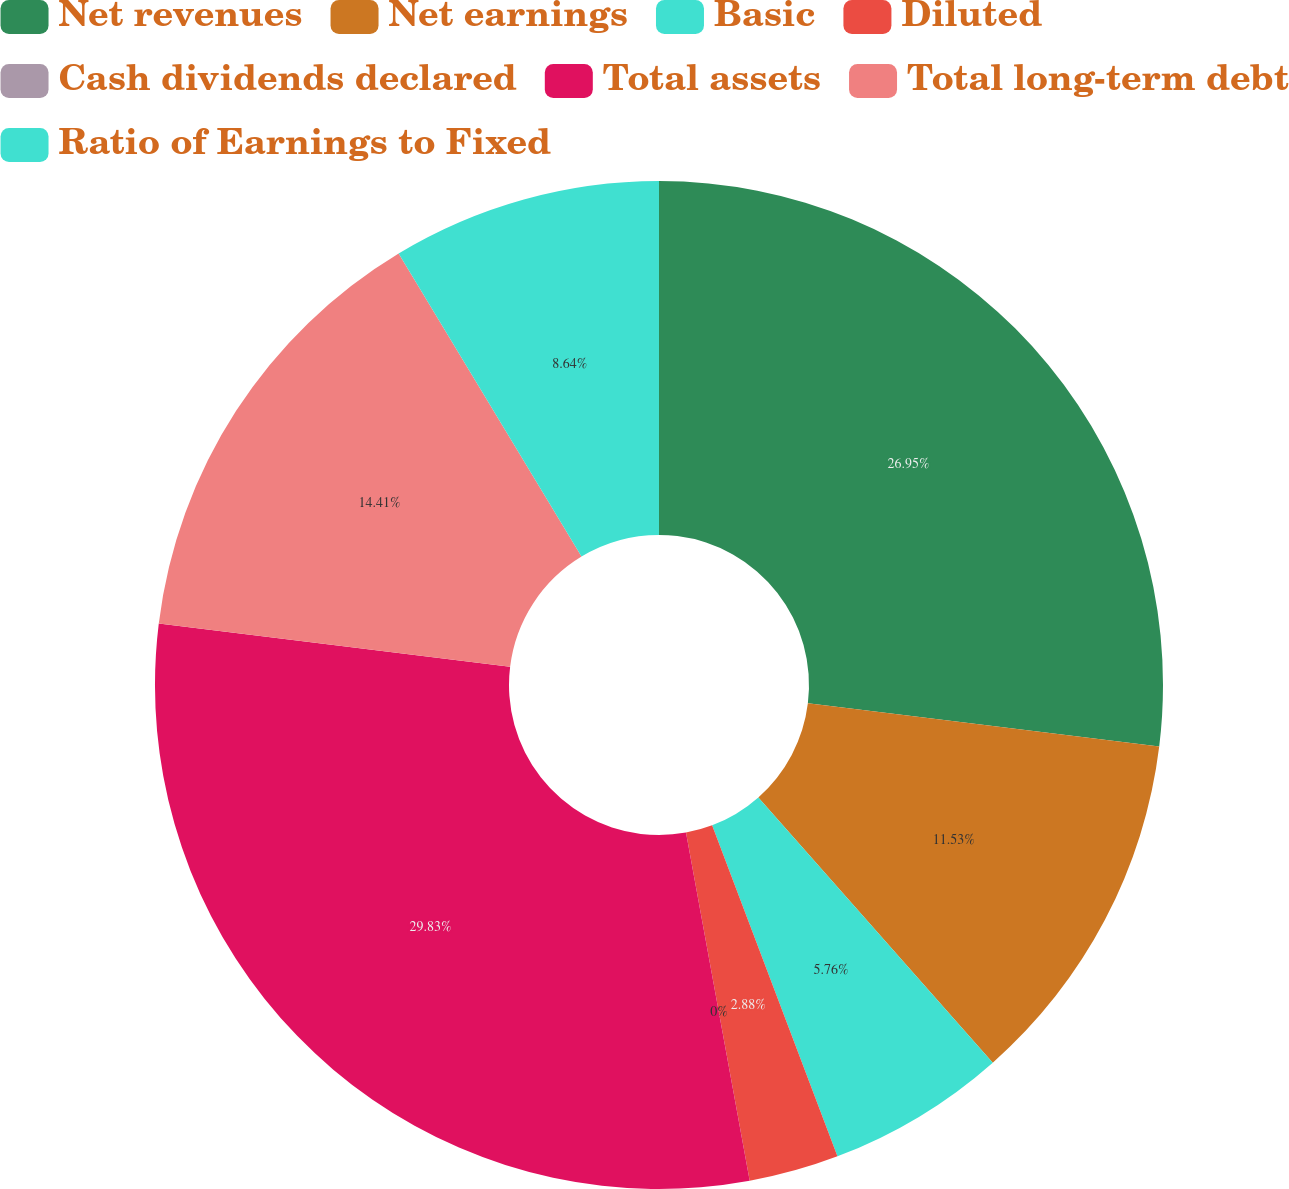<chart> <loc_0><loc_0><loc_500><loc_500><pie_chart><fcel>Net revenues<fcel>Net earnings<fcel>Basic<fcel>Diluted<fcel>Cash dividends declared<fcel>Total assets<fcel>Total long-term debt<fcel>Ratio of Earnings to Fixed<nl><fcel>26.95%<fcel>11.53%<fcel>5.76%<fcel>2.88%<fcel>0.0%<fcel>29.83%<fcel>14.41%<fcel>8.64%<nl></chart> 